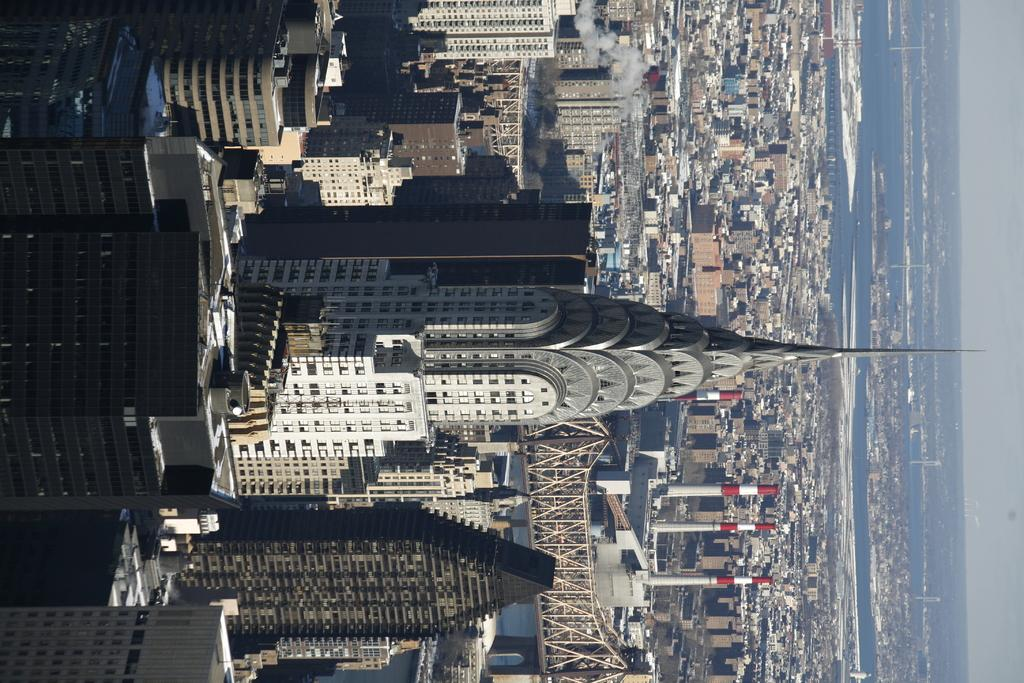What type of structures can be seen in the image? There are buildings in the image. What connects the two sides of the water in the image? There is a bridge in the image. What natural element is visible in the image? Water is visible in the image. What can be seen in the background of the image? The sky is visible in the background of the image. What type of voice can be heard coming from the buildings in the image? There is no indication of any sound or voice in the image, as it only shows buildings, a bridge, water, and the sky. 